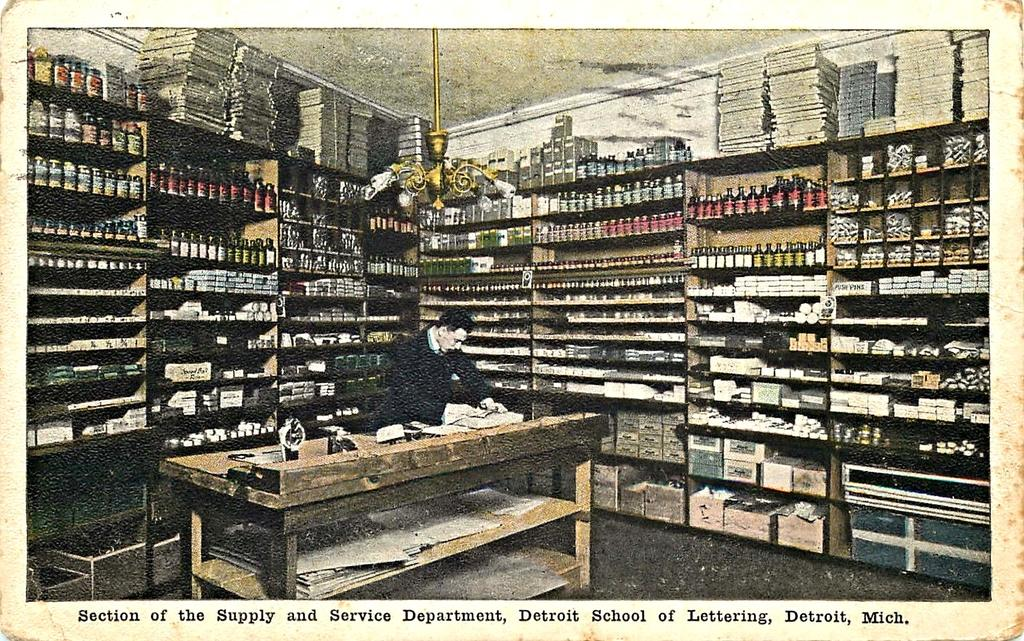Provide a one-sentence caption for the provided image. A photo of a man in a room with packed shelves at the Supply and Service Department in Michigan. 